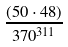Convert formula to latex. <formula><loc_0><loc_0><loc_500><loc_500>\frac { ( 5 0 \cdot 4 8 ) } { 3 7 0 ^ { 3 1 1 } }</formula> 